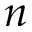<formula> <loc_0><loc_0><loc_500><loc_500>n</formula> 